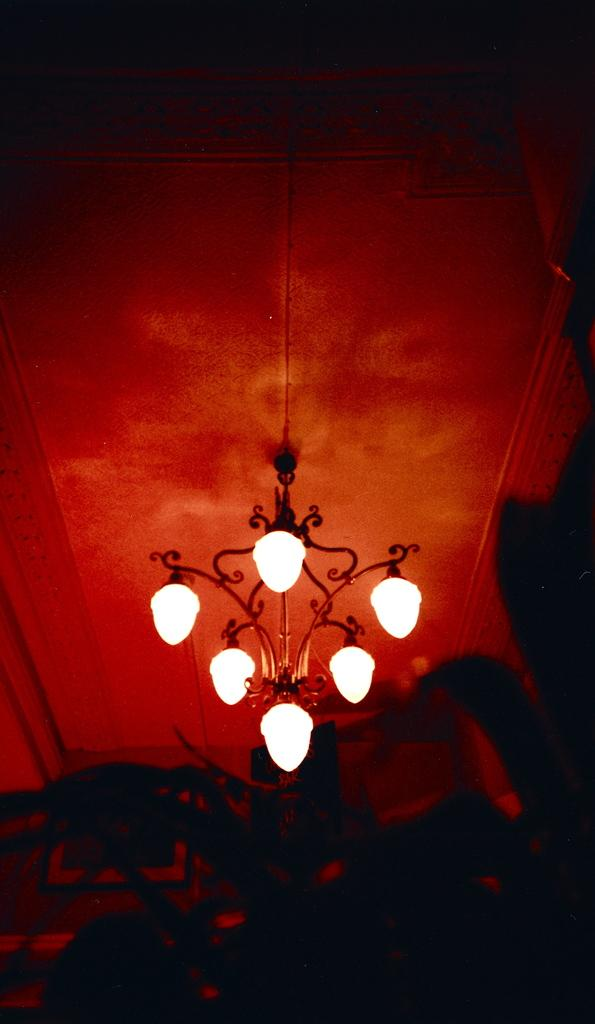What type of lighting fixture is present in the image? There is a chandelier in the image. How is the chandelier depicted in the image? The chandelier is blown in the image. Where is the chandelier located in the image? The chandelier is located at the ceiling. How does one pull the chandelier in the image? There is no action of pulling the chandelier in the image; it is a static representation of a blown chandelier. 